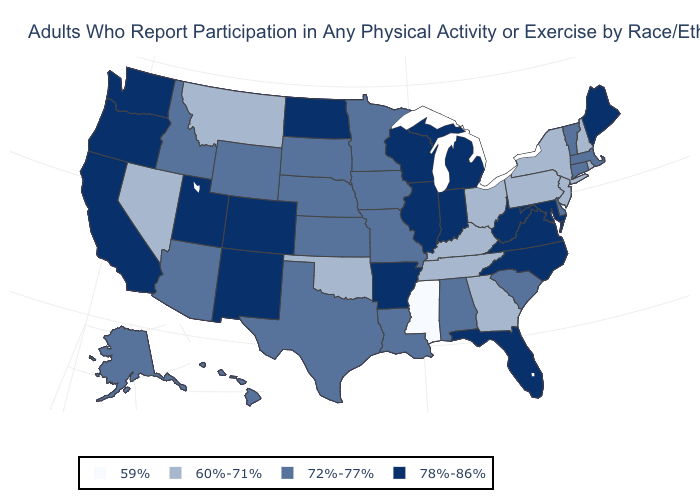Name the states that have a value in the range 59%?
Short answer required. Mississippi. What is the value of Georgia?
Quick response, please. 60%-71%. Name the states that have a value in the range 59%?
Keep it brief. Mississippi. Does Vermont have the highest value in the USA?
Quick response, please. No. What is the highest value in states that border New Jersey?
Be succinct. 72%-77%. Name the states that have a value in the range 78%-86%?
Short answer required. Arkansas, California, Colorado, Florida, Illinois, Indiana, Maine, Maryland, Michigan, New Mexico, North Carolina, North Dakota, Oregon, Utah, Virginia, Washington, West Virginia, Wisconsin. What is the lowest value in the West?
Keep it brief. 60%-71%. What is the lowest value in states that border Maryland?
Short answer required. 60%-71%. What is the value of Kansas?
Give a very brief answer. 72%-77%. Does Hawaii have the highest value in the West?
Answer briefly. No. Name the states that have a value in the range 59%?
Quick response, please. Mississippi. Does Georgia have the lowest value in the South?
Concise answer only. No. Does Georgia have the same value as Texas?
Give a very brief answer. No. Name the states that have a value in the range 59%?
Quick response, please. Mississippi. What is the value of Connecticut?
Keep it brief. 72%-77%. 